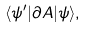<formula> <loc_0><loc_0><loc_500><loc_500>\langle \psi ^ { \prime } | \partial A | \psi \rangle ,</formula> 